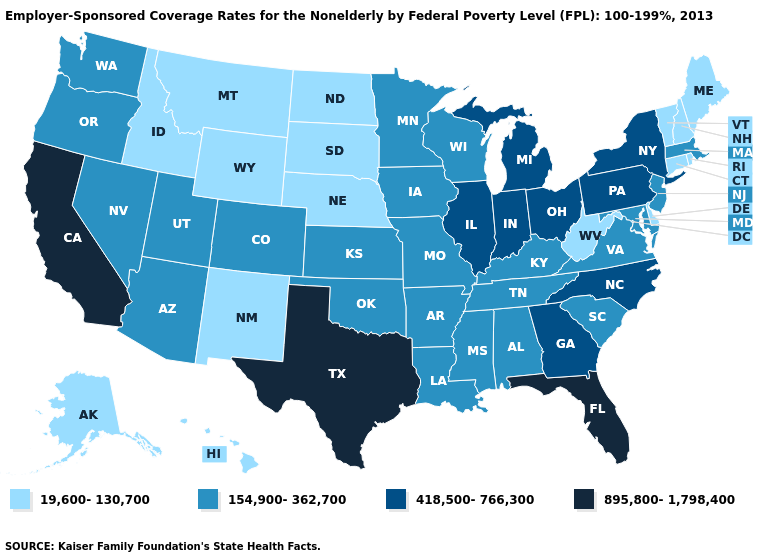What is the value of Illinois?
Concise answer only. 418,500-766,300. Does the map have missing data?
Concise answer only. No. Name the states that have a value in the range 19,600-130,700?
Write a very short answer. Alaska, Connecticut, Delaware, Hawaii, Idaho, Maine, Montana, Nebraska, New Hampshire, New Mexico, North Dakota, Rhode Island, South Dakota, Vermont, West Virginia, Wyoming. What is the value of Montana?
Write a very short answer. 19,600-130,700. Does Wyoming have the lowest value in the West?
Short answer required. Yes. What is the lowest value in the USA?
Answer briefly. 19,600-130,700. Among the states that border Kentucky , does Indiana have the lowest value?
Give a very brief answer. No. Does Alaska have the lowest value in the USA?
Write a very short answer. Yes. What is the value of New Hampshire?
Quick response, please. 19,600-130,700. Name the states that have a value in the range 418,500-766,300?
Write a very short answer. Georgia, Illinois, Indiana, Michigan, New York, North Carolina, Ohio, Pennsylvania. What is the lowest value in the USA?
Quick response, please. 19,600-130,700. Name the states that have a value in the range 895,800-1,798,400?
Quick response, please. California, Florida, Texas. Does Georgia have a higher value than Kentucky?
Concise answer only. Yes. Does Oregon have the lowest value in the West?
Answer briefly. No. 